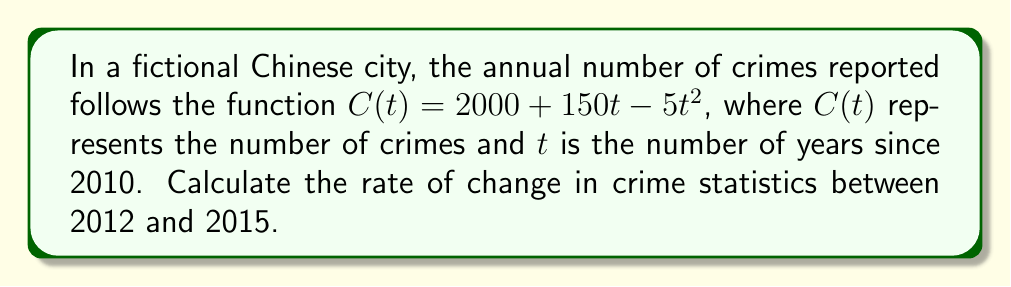Provide a solution to this math problem. To find the rate of change between 2012 and 2015, we need to:

1. Calculate the number of crimes in 2012 (t = 2) and 2015 (t = 5):

   For 2012: $C(2) = 2000 + 150(2) - 5(2)^2 = 2000 + 300 - 20 = 2280$
   For 2015: $C(5) = 2000 + 150(5) - 5(5)^2 = 2000 + 750 - 125 = 2625$

2. Calculate the change in crimes:
   $\Delta C = C(5) - C(2) = 2625 - 2280 = 345$

3. Calculate the change in time:
   $\Delta t = 5 - 2 = 3$ years

4. Calculate the rate of change:
   Rate of change = $\frac{\Delta C}{\Delta t} = \frac{345}{3} = 115$

Therefore, the rate of change in crime statistics between 2012 and 2015 is 115 crimes per year.
Answer: 115 crimes/year 